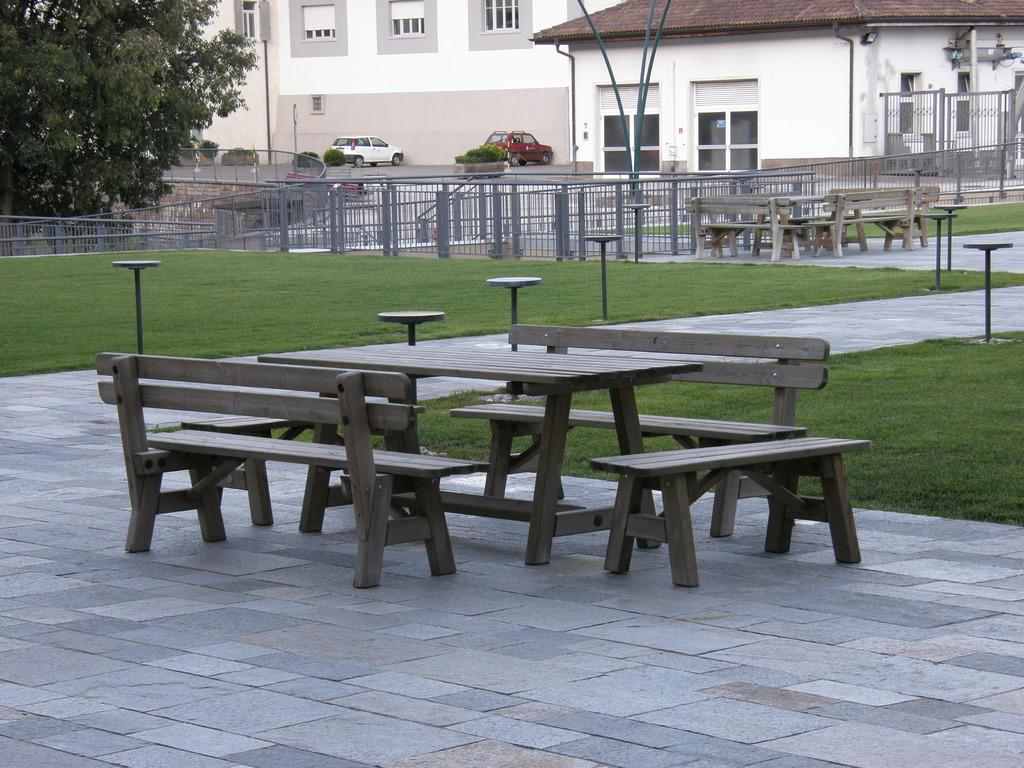What type of seating is present in the image? There are benches in the image. What other furniture is present in the image? There are tables in the image. What can be seen in the background of the image? There are buildings with windows, vehicles, a fence, a tree, and plants in the background. What type of ground surface is visible in the image? There is grass visible in the image. Can you see a parent holding a match and wearing a veil in the image? There is no parent, match, or veil present in the image. 